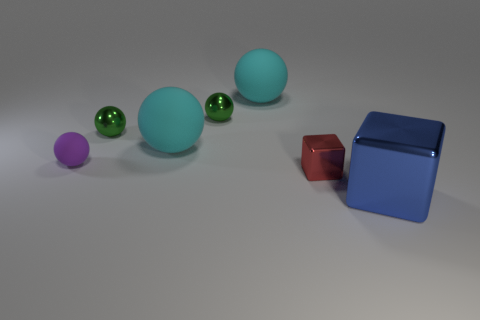Subtract all tiny purple rubber balls. How many balls are left? 4 Subtract all purple spheres. How many spheres are left? 4 Subtract 1 spheres. How many spheres are left? 4 Subtract all blue balls. Subtract all gray blocks. How many balls are left? 5 Add 1 tiny gray shiny objects. How many objects exist? 8 Subtract all balls. How many objects are left? 2 Subtract 0 red cylinders. How many objects are left? 7 Subtract all small red blocks. Subtract all large blue blocks. How many objects are left? 5 Add 3 large blue cubes. How many large blue cubes are left? 4 Add 2 small matte things. How many small matte things exist? 3 